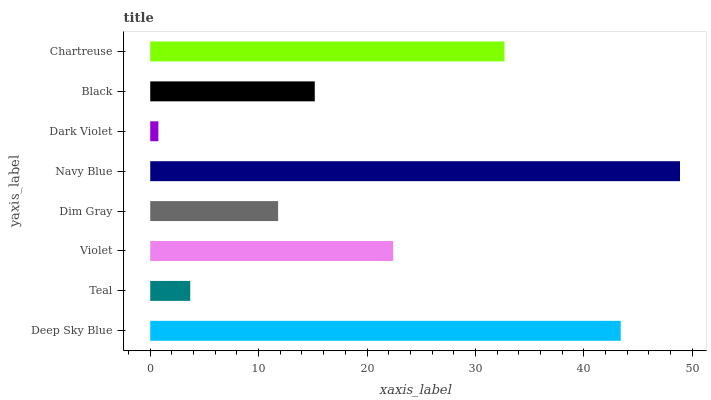Is Dark Violet the minimum?
Answer yes or no. Yes. Is Navy Blue the maximum?
Answer yes or no. Yes. Is Teal the minimum?
Answer yes or no. No. Is Teal the maximum?
Answer yes or no. No. Is Deep Sky Blue greater than Teal?
Answer yes or no. Yes. Is Teal less than Deep Sky Blue?
Answer yes or no. Yes. Is Teal greater than Deep Sky Blue?
Answer yes or no. No. Is Deep Sky Blue less than Teal?
Answer yes or no. No. Is Violet the high median?
Answer yes or no. Yes. Is Black the low median?
Answer yes or no. Yes. Is Dark Violet the high median?
Answer yes or no. No. Is Teal the low median?
Answer yes or no. No. 